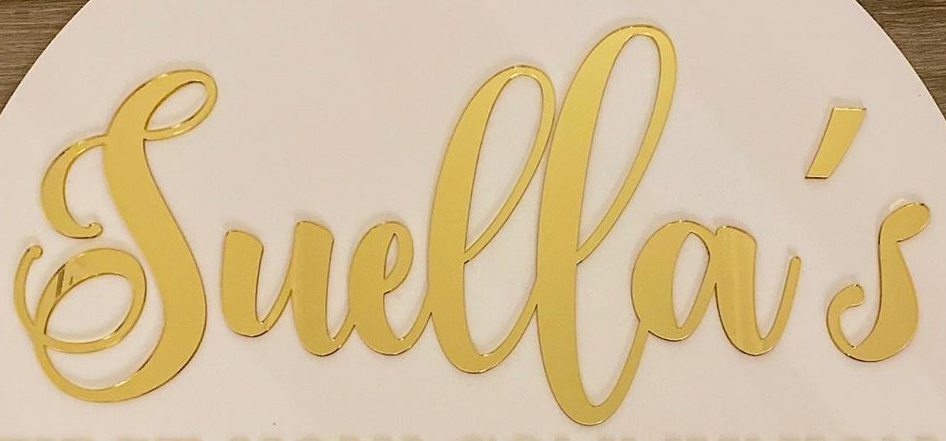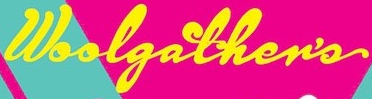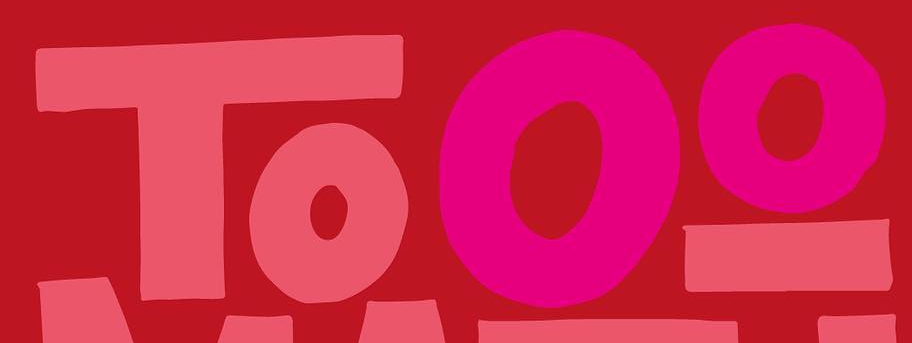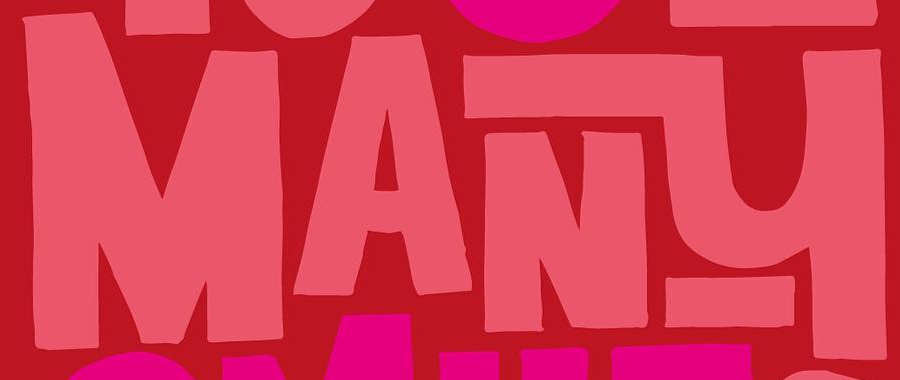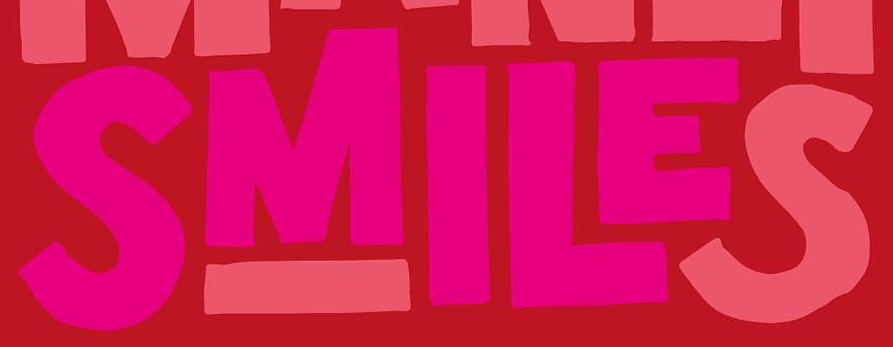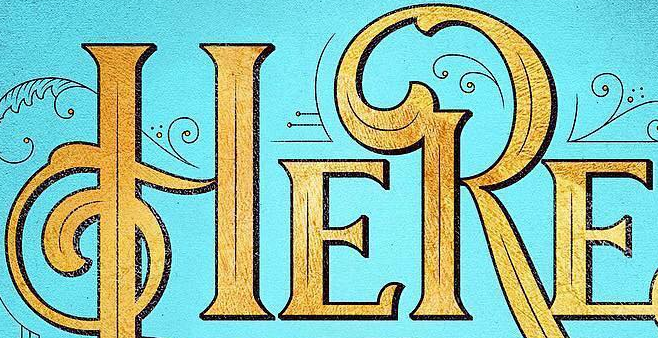What text appears in these images from left to right, separated by a semicolon? Suella's; Woolgather's; Tooo; MANY; SMILES; HERE 